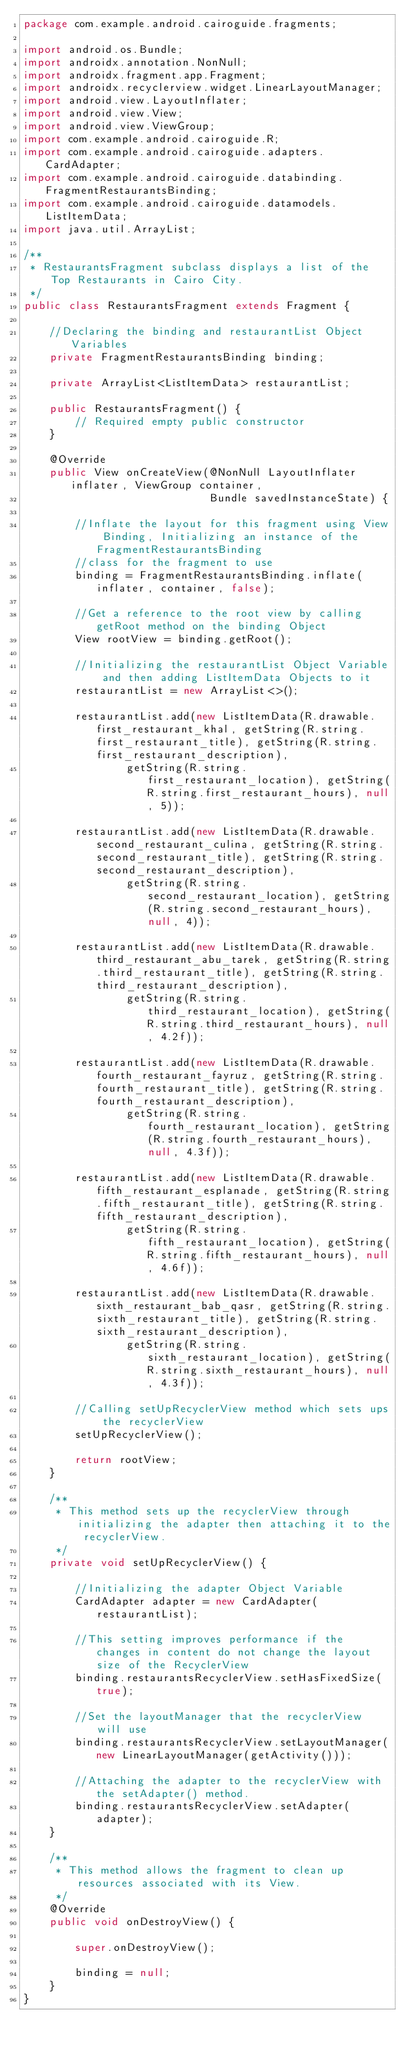Convert code to text. <code><loc_0><loc_0><loc_500><loc_500><_Java_>package com.example.android.cairoguide.fragments;

import android.os.Bundle;
import androidx.annotation.NonNull;
import androidx.fragment.app.Fragment;
import androidx.recyclerview.widget.LinearLayoutManager;
import android.view.LayoutInflater;
import android.view.View;
import android.view.ViewGroup;
import com.example.android.cairoguide.R;
import com.example.android.cairoguide.adapters.CardAdapter;
import com.example.android.cairoguide.databinding.FragmentRestaurantsBinding;
import com.example.android.cairoguide.datamodels.ListItemData;
import java.util.ArrayList;

/**
 * RestaurantsFragment subclass displays a list of the Top Restaurants in Cairo City.
 */
public class RestaurantsFragment extends Fragment {

    //Declaring the binding and restaurantList Object Variables
    private FragmentRestaurantsBinding binding;

    private ArrayList<ListItemData> restaurantList;

    public RestaurantsFragment() {
        // Required empty public constructor
    }

    @Override
    public View onCreateView(@NonNull LayoutInflater inflater, ViewGroup container,
                             Bundle savedInstanceState) {

        //Inflate the layout for this fragment using View Binding, Initializing an instance of the FragmentRestaurantsBinding
        //class for the fragment to use
        binding = FragmentRestaurantsBinding.inflate(inflater, container, false);

        //Get a reference to the root view by calling getRoot method on the binding Object
        View rootView = binding.getRoot();

        //Initializing the restaurantList Object Variable and then adding ListItemData Objects to it
        restaurantList = new ArrayList<>();

        restaurantList.add(new ListItemData(R.drawable.first_restaurant_khal, getString(R.string.first_restaurant_title), getString(R.string.first_restaurant_description),
                getString(R.string.first_restaurant_location), getString(R.string.first_restaurant_hours), null, 5));

        restaurantList.add(new ListItemData(R.drawable.second_restaurant_culina, getString(R.string.second_restaurant_title), getString(R.string.second_restaurant_description),
                getString(R.string.second_restaurant_location), getString(R.string.second_restaurant_hours), null, 4));

        restaurantList.add(new ListItemData(R.drawable.third_restaurant_abu_tarek, getString(R.string.third_restaurant_title), getString(R.string.third_restaurant_description),
                getString(R.string.third_restaurant_location), getString(R.string.third_restaurant_hours), null, 4.2f));

        restaurantList.add(new ListItemData(R.drawable.fourth_restaurant_fayruz, getString(R.string.fourth_restaurant_title), getString(R.string.fourth_restaurant_description),
                getString(R.string.fourth_restaurant_location), getString(R.string.fourth_restaurant_hours), null, 4.3f));

        restaurantList.add(new ListItemData(R.drawable.fifth_restaurant_esplanade, getString(R.string.fifth_restaurant_title), getString(R.string.fifth_restaurant_description),
                getString(R.string.fifth_restaurant_location), getString(R.string.fifth_restaurant_hours), null, 4.6f));

        restaurantList.add(new ListItemData(R.drawable.sixth_restaurant_bab_qasr, getString(R.string.sixth_restaurant_title), getString(R.string.sixth_restaurant_description),
                getString(R.string.sixth_restaurant_location), getString(R.string.sixth_restaurant_hours), null, 4.3f));

        //Calling setUpRecyclerView method which sets ups the recyclerView
        setUpRecyclerView();

        return rootView;
    }

    /**
     * This method sets up the recyclerView through initializing the adapter then attaching it to the recyclerView.
     */
    private void setUpRecyclerView() {

        //Initializing the adapter Object Variable
        CardAdapter adapter = new CardAdapter(restaurantList);

        //This setting improves performance if the changes in content do not change the layout size of the RecyclerView
        binding.restaurantsRecyclerView.setHasFixedSize(true);

        //Set the layoutManager that the recyclerView will use
        binding.restaurantsRecyclerView.setLayoutManager(new LinearLayoutManager(getActivity()));

        //Attaching the adapter to the recyclerView with the setAdapter() method.
        binding.restaurantsRecyclerView.setAdapter(adapter);
    }

    /**
     * This method allows the fragment to clean up resources associated with its View.
     */
    @Override
    public void onDestroyView() {

        super.onDestroyView();

        binding = null;
    }
}


</code> 